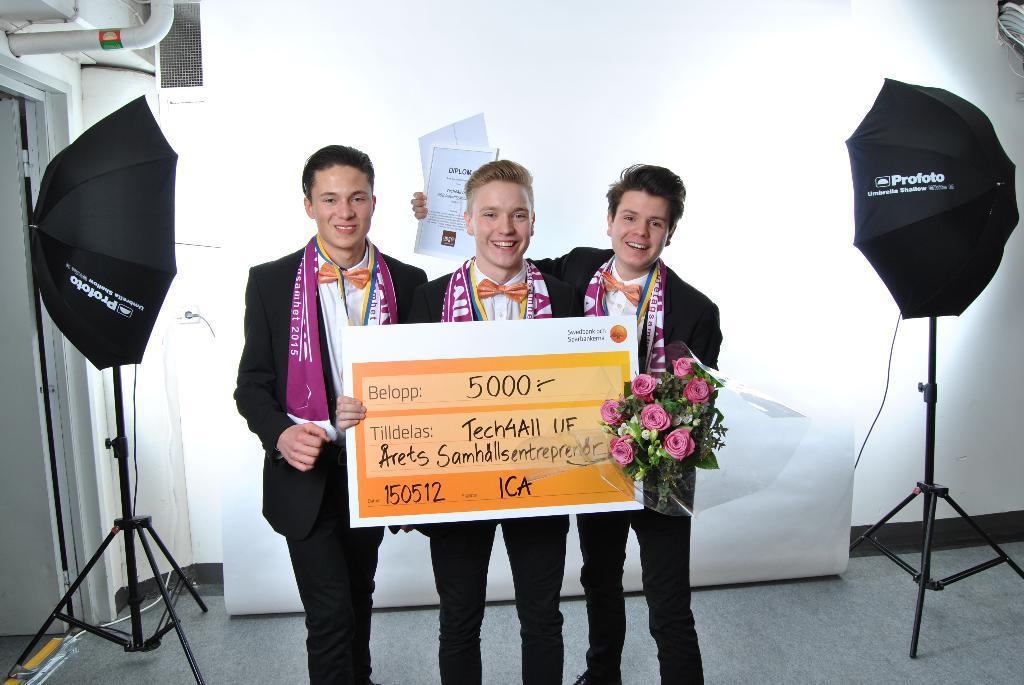In one or two sentences, can you explain what this image depicts? In this picture we can see three men, they are smiling, the right side person is holding a flower bouquet and few papers in his hands, beside to them we can find few umbrellas and stands, and also we can see a sofa and a pipe. 